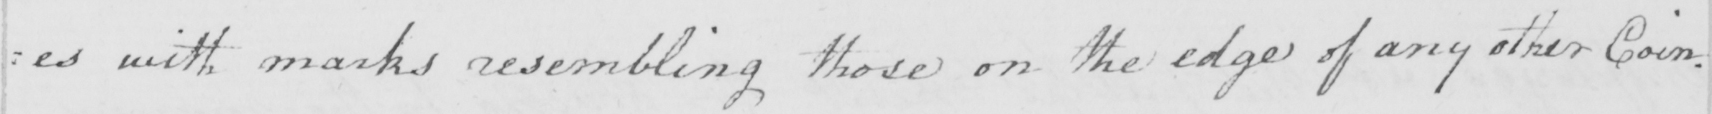Please provide the text content of this handwritten line. : es with marks resembling those on the edge of any other Coin . 